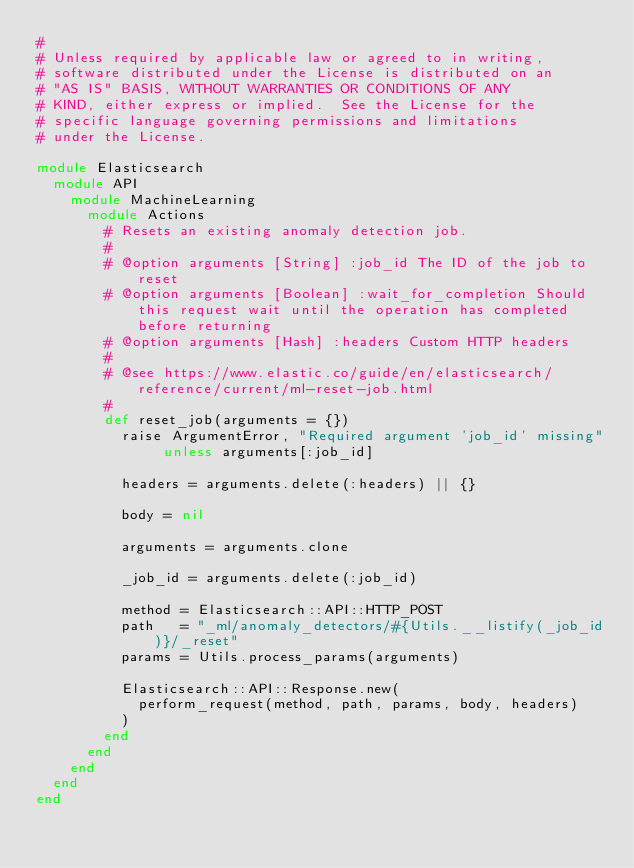<code> <loc_0><loc_0><loc_500><loc_500><_Ruby_>#
# Unless required by applicable law or agreed to in writing,
# software distributed under the License is distributed on an
# "AS IS" BASIS, WITHOUT WARRANTIES OR CONDITIONS OF ANY
# KIND, either express or implied.  See the License for the
# specific language governing permissions and limitations
# under the License.

module Elasticsearch
  module API
    module MachineLearning
      module Actions
        # Resets an existing anomaly detection job.
        #
        # @option arguments [String] :job_id The ID of the job to reset
        # @option arguments [Boolean] :wait_for_completion Should this request wait until the operation has completed before returning
        # @option arguments [Hash] :headers Custom HTTP headers
        #
        # @see https://www.elastic.co/guide/en/elasticsearch/reference/current/ml-reset-job.html
        #
        def reset_job(arguments = {})
          raise ArgumentError, "Required argument 'job_id' missing" unless arguments[:job_id]

          headers = arguments.delete(:headers) || {}

          body = nil

          arguments = arguments.clone

          _job_id = arguments.delete(:job_id)

          method = Elasticsearch::API::HTTP_POST
          path   = "_ml/anomaly_detectors/#{Utils.__listify(_job_id)}/_reset"
          params = Utils.process_params(arguments)

          Elasticsearch::API::Response.new(
            perform_request(method, path, params, body, headers)
          )
        end
      end
    end
  end
end
</code> 